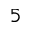Convert formula to latex. <formula><loc_0><loc_0><loc_500><loc_500>_ { 5 }</formula> 